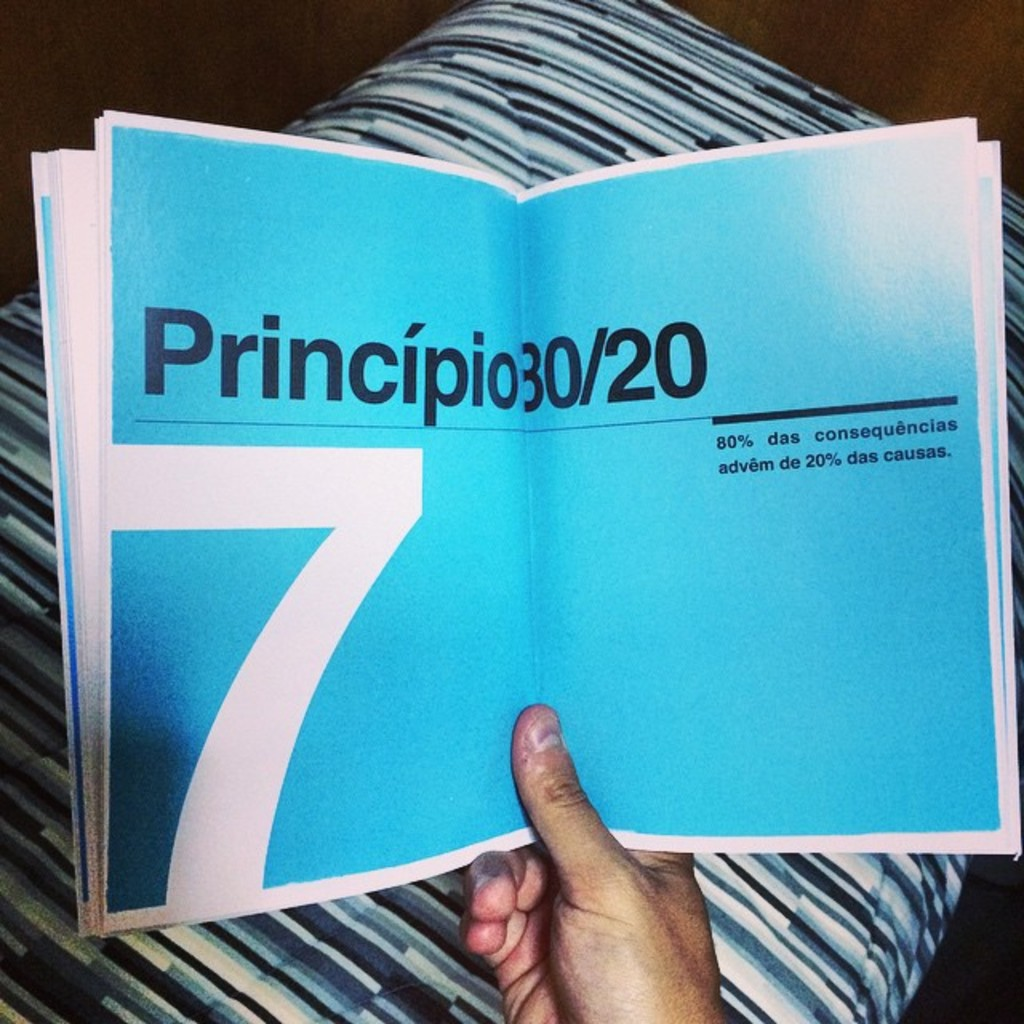How does the physical appearance of the book contribute to the themes discussed within? The bold cyan blue cover of the book makes a significant visual impact, suggesting themes of clarity and depth which are essential in discussions about efficiency and productivity principles. This vibrant hue might be chosen to grab the reader’s attention and make the philosophical or operational content stand out, encouraging deeper engagement. Furthermore, the clean, minimalist text design inside the book aligns with the theme of reducing clutter to focus on core outcomes, reflective of the 80/20 rule discussed within. 